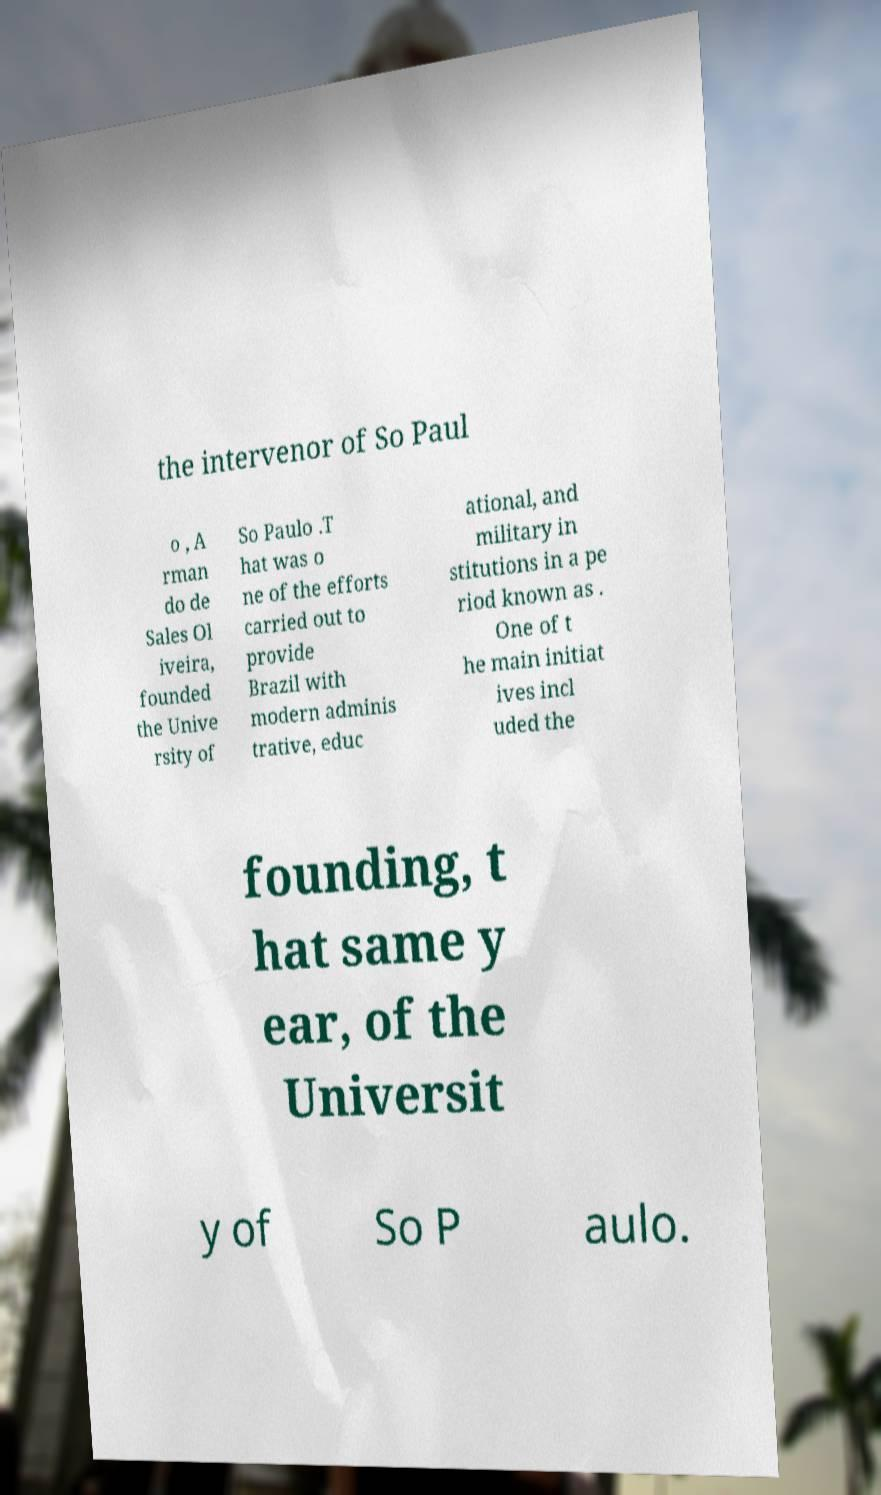For documentation purposes, I need the text within this image transcribed. Could you provide that? the intervenor of So Paul o , A rman do de Sales Ol iveira, founded the Unive rsity of So Paulo .T hat was o ne of the efforts carried out to provide Brazil with modern adminis trative, educ ational, and military in stitutions in a pe riod known as . One of t he main initiat ives incl uded the founding, t hat same y ear, of the Universit y of So P aulo. 